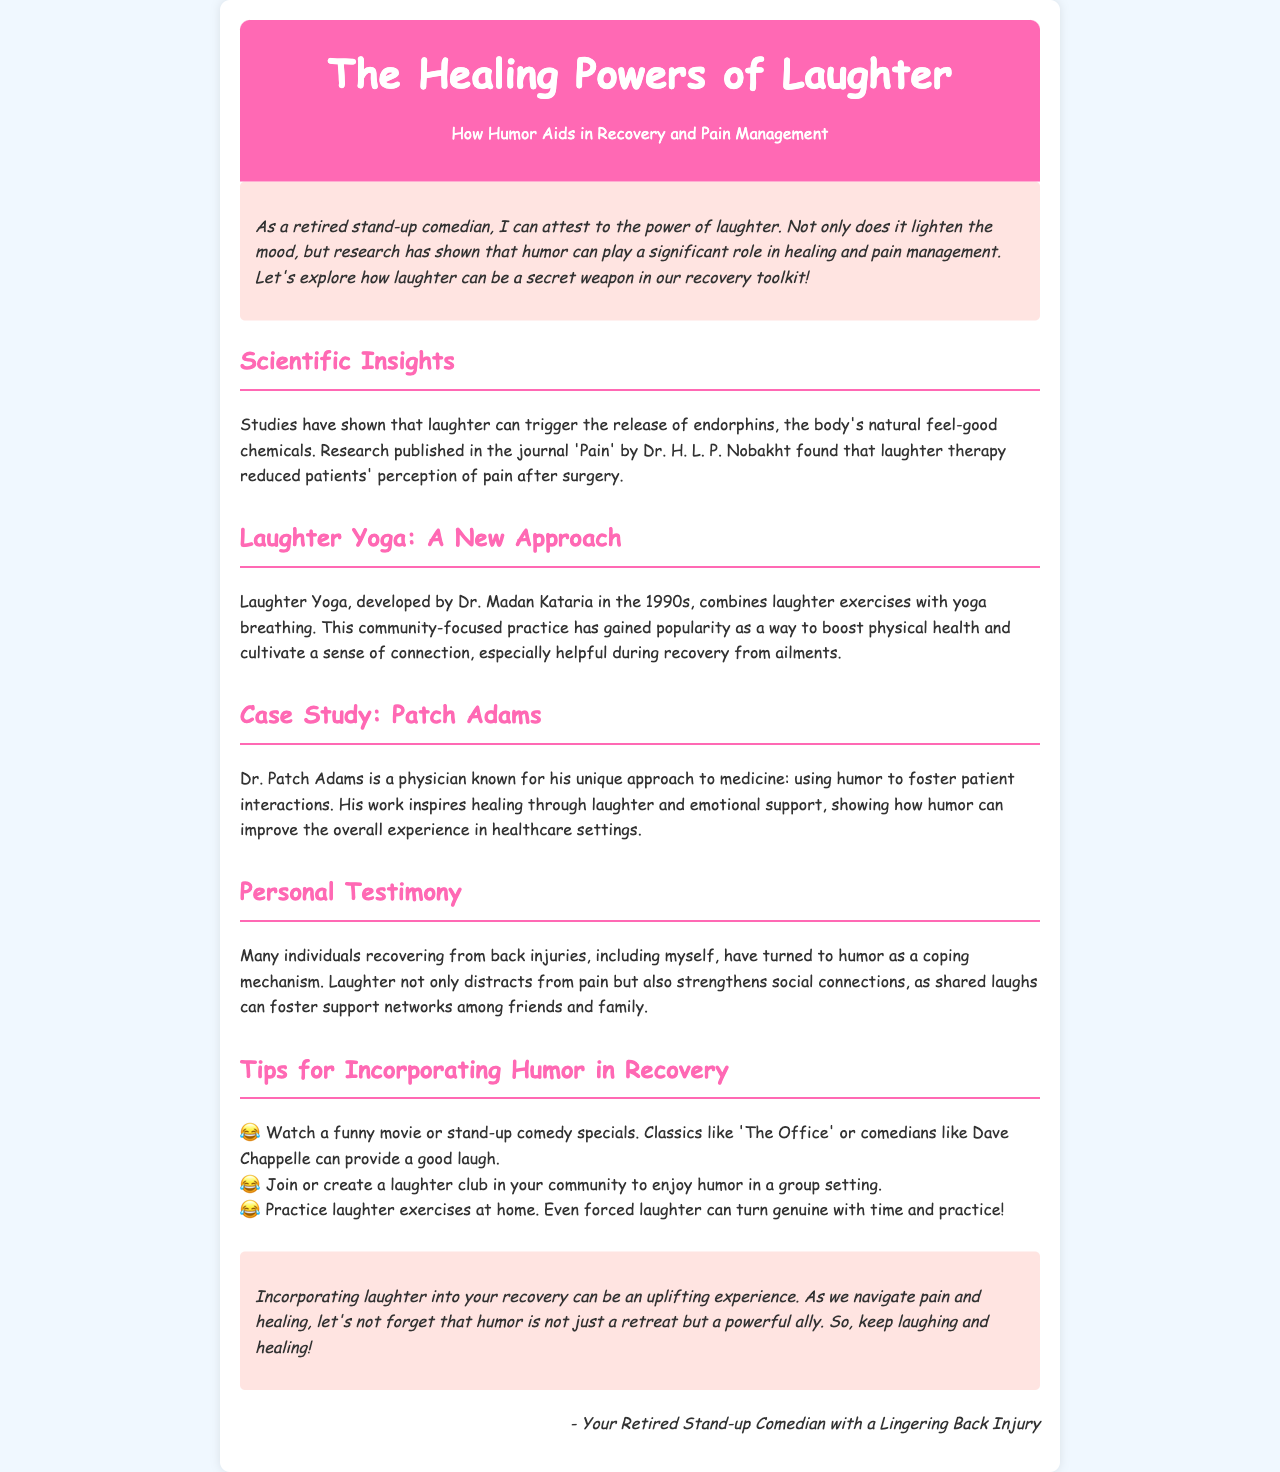what is the title of the newsletter? The title of the newsletter is provided in the header section, prominently displayed as the main heading.
Answer: The Healing Powers of Laughter who developed Laughter Yoga? The document mentions Dr. Madan Kataria as the developer of Laughter Yoga.
Answer: Dr. Madan Kataria which journal published research on laughter therapy? The research discussed is published in the journal 'Pain'.
Answer: Pain what type of therapy reduced pain perception after surgery? The document states that laughter therapy is the type of therapy that reduced pain perception.
Answer: Laughter therapy what is the primary benefit of laughter mentioned in the newsletter? The newsletter emphasizes laughter's role in releasing endorphins, which are natural feel-good chemicals.
Answer: Release of endorphins how can humor strengthen social connections according to the document? The document explains that shared laughs can foster support networks among friends and family, especially during recovery.
Answer: Shared laughs what is one tip for incorporating humor in recovery? One tip provided is to watch a funny movie or stand-up comedy specials.
Answer: Watch a funny movie who is known for using humor in patient interactions? The document identifies Dr. Patch Adams as known for this unique approach in medicine.
Answer: Dr. Patch Adams 